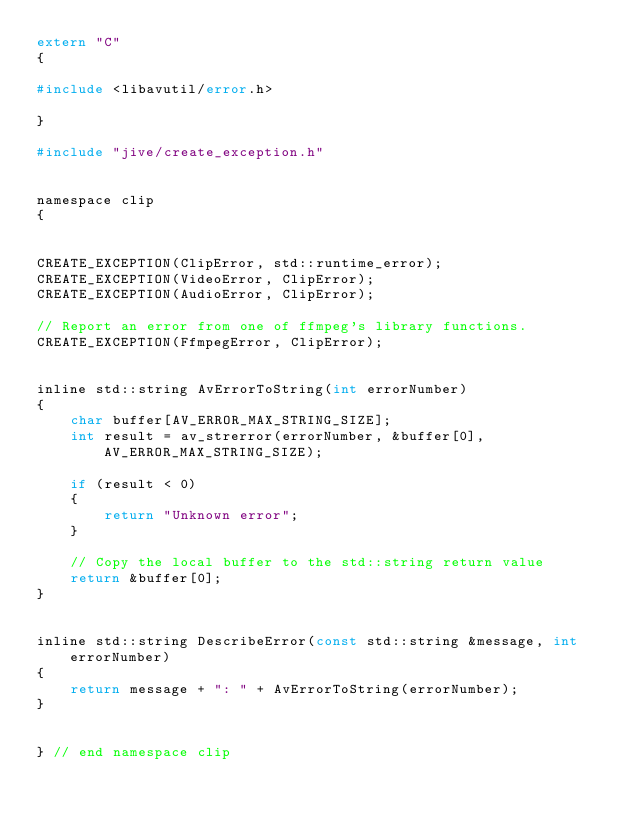<code> <loc_0><loc_0><loc_500><loc_500><_C_>extern "C"
{

#include <libavutil/error.h>

}

#include "jive/create_exception.h"


namespace clip
{


CREATE_EXCEPTION(ClipError, std::runtime_error);
CREATE_EXCEPTION(VideoError, ClipError);
CREATE_EXCEPTION(AudioError, ClipError);

// Report an error from one of ffmpeg's library functions.
CREATE_EXCEPTION(FfmpegError, ClipError);


inline std::string AvErrorToString(int errorNumber)
{
    char buffer[AV_ERROR_MAX_STRING_SIZE];
    int result = av_strerror(errorNumber, &buffer[0], AV_ERROR_MAX_STRING_SIZE);

    if (result < 0)
    {
        return "Unknown error";
    }

    // Copy the local buffer to the std::string return value
    return &buffer[0];
}


inline std::string DescribeError(const std::string &message, int errorNumber)
{
    return message + ": " + AvErrorToString(errorNumber);
}


} // end namespace clip
</code> 